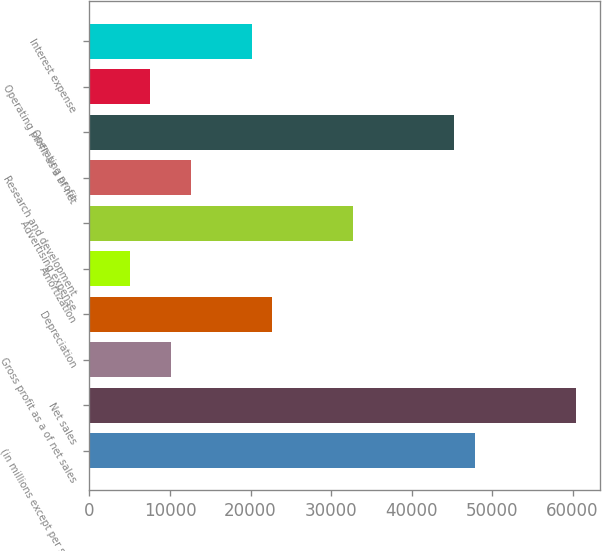Convert chart. <chart><loc_0><loc_0><loc_500><loc_500><bar_chart><fcel>(in millions except per share<fcel>Net sales<fcel>Gross profit as a of net sales<fcel>Depreciation<fcel>Amortization<fcel>Advertising expense<fcel>Research and development<fcel>Operating profit<fcel>Operating profit as a of net<fcel>Interest expense<nl><fcel>47824<fcel>60409<fcel>10069<fcel>22654<fcel>5035.01<fcel>32722<fcel>12586<fcel>45307<fcel>7552.01<fcel>20137<nl></chart> 